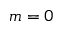<formula> <loc_0><loc_0><loc_500><loc_500>m = 0</formula> 